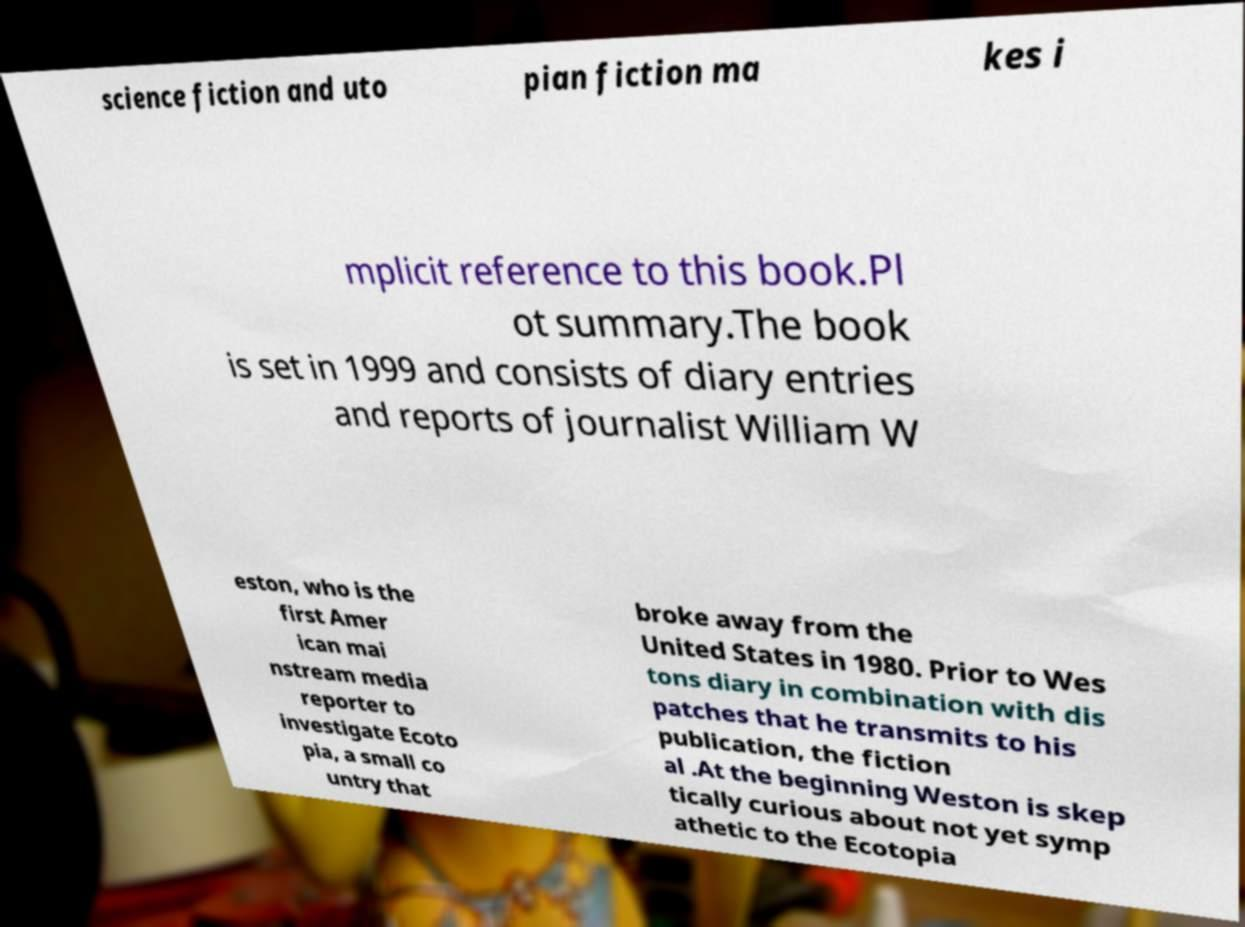Please identify and transcribe the text found in this image. science fiction and uto pian fiction ma kes i mplicit reference to this book.Pl ot summary.The book is set in 1999 and consists of diary entries and reports of journalist William W eston, who is the first Amer ican mai nstream media reporter to investigate Ecoto pia, a small co untry that broke away from the United States in 1980. Prior to Wes tons diary in combination with dis patches that he transmits to his publication, the fiction al .At the beginning Weston is skep tically curious about not yet symp athetic to the Ecotopia 